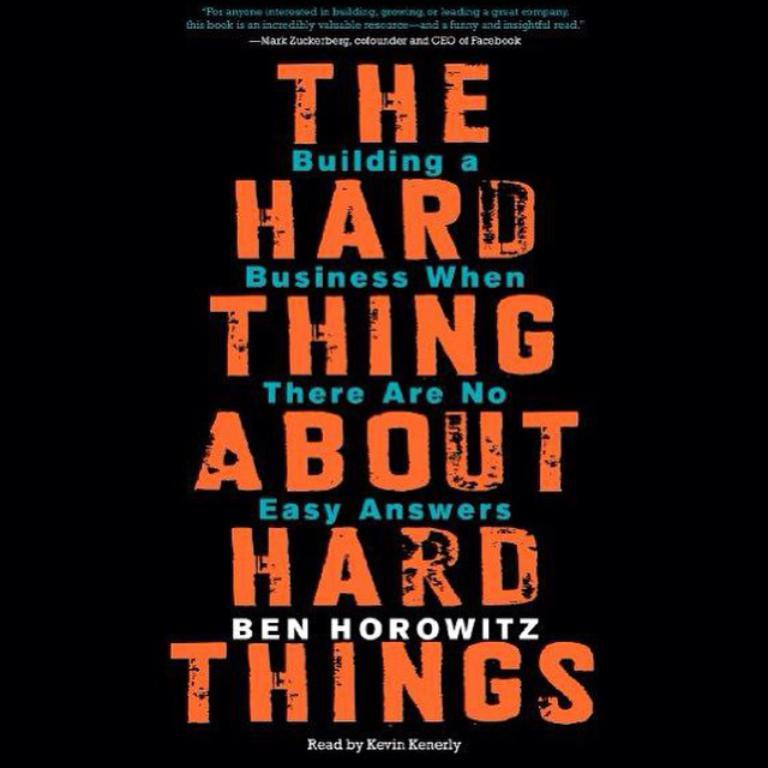Provide a one-sentence caption for the provided image. The cover of an audio book by Ben Horowitz read by Kevin Kenerly. 